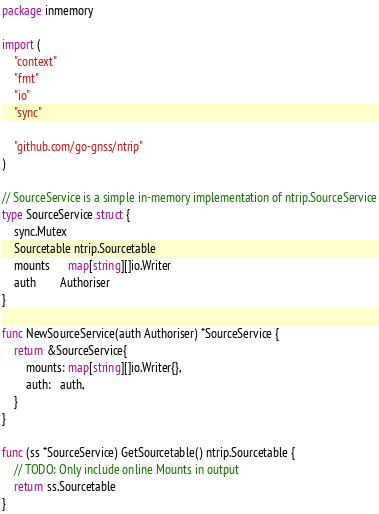Convert code to text. <code><loc_0><loc_0><loc_500><loc_500><_Go_>package inmemory

import (
	"context"
	"fmt"
	"io"
	"sync"

	"github.com/go-gnss/ntrip"
)

// SourceService is a simple in-memory implementation of ntrip.SourceService
type SourceService struct {
	sync.Mutex
	Sourcetable ntrip.Sourcetable
	mounts      map[string][]io.Writer
	auth        Authoriser
}

func NewSourceService(auth Authoriser) *SourceService {
	return &SourceService{
		mounts: map[string][]io.Writer{},
		auth:   auth,
	}
}

func (ss *SourceService) GetSourcetable() ntrip.Sourcetable {
	// TODO: Only include online Mounts in output
	return ss.Sourcetable
}
</code> 